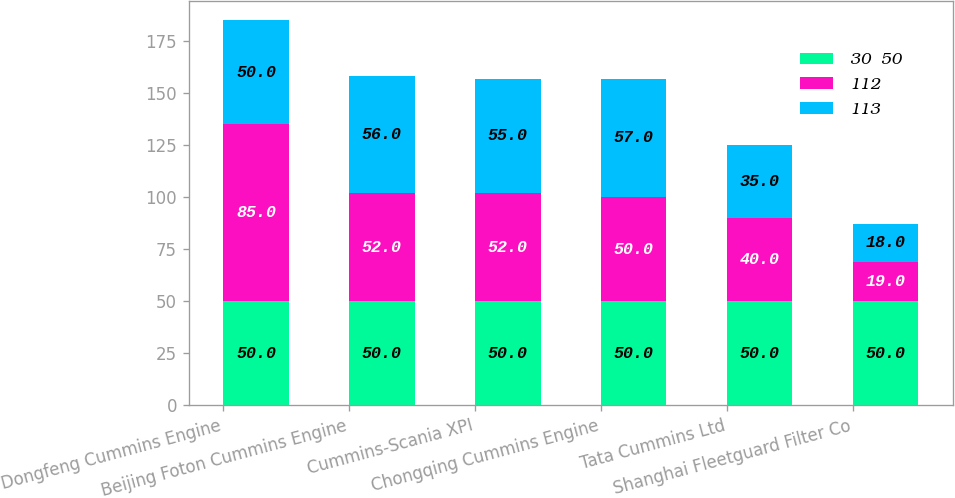Convert chart. <chart><loc_0><loc_0><loc_500><loc_500><stacked_bar_chart><ecel><fcel>Dongfeng Cummins Engine<fcel>Beijing Foton Cummins Engine<fcel>Cummins-Scania XPI<fcel>Chongqing Cummins Engine<fcel>Tata Cummins Ltd<fcel>Shanghai Fleetguard Filter Co<nl><fcel>30  50<fcel>50<fcel>50<fcel>50<fcel>50<fcel>50<fcel>50<nl><fcel>112<fcel>85<fcel>52<fcel>52<fcel>50<fcel>40<fcel>19<nl><fcel>113<fcel>50<fcel>56<fcel>55<fcel>57<fcel>35<fcel>18<nl></chart> 